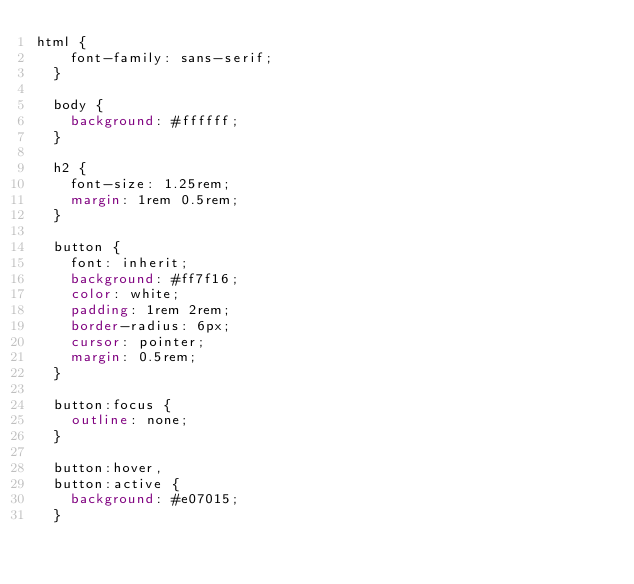Convert code to text. <code><loc_0><loc_0><loc_500><loc_500><_CSS_>html {
    font-family: sans-serif;
  }
  
  body {
    background: #ffffff;
  }
  
  h2 {
    font-size: 1.25rem;
    margin: 1rem 0.5rem;
  }
  
  button {
    font: inherit;
    background: #ff7f16;
    color: white;
    padding: 1rem 2rem;
    border-radius: 6px;
    cursor: pointer;
    margin: 0.5rem;
  }
  
  button:focus {
    outline: none;
  }
  
  button:hover,
  button:active {
    background: #e07015;
  }</code> 